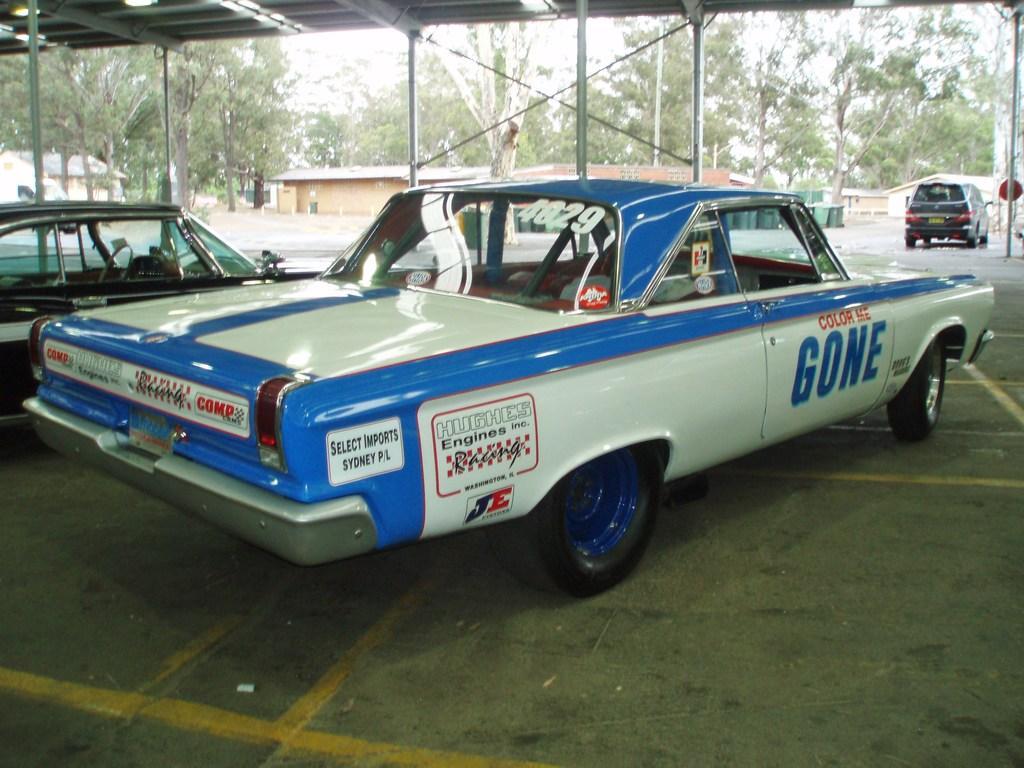How would you summarize this image in a sentence or two? In this image there are cars under the shed. On top of the image there are lights. In the background of the image there are buildings, trees and sky. 